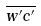Convert formula to latex. <formula><loc_0><loc_0><loc_500><loc_500>\overline { w ^ { \prime } c ^ { \prime } }</formula> 